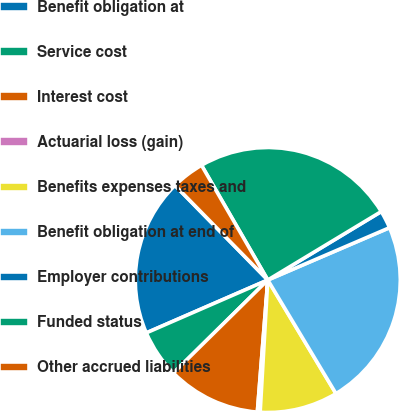Convert chart to OTSL. <chart><loc_0><loc_0><loc_500><loc_500><pie_chart><fcel>Benefit obligation at<fcel>Service cost<fcel>Interest cost<fcel>Actuarial loss (gain)<fcel>Benefits expenses taxes and<fcel>Benefit obligation at end of<fcel>Employer contributions<fcel>Funded status<fcel>Other accrued liabilities<nl><fcel>19.19%<fcel>5.85%<fcel>11.36%<fcel>0.34%<fcel>9.52%<fcel>22.86%<fcel>2.18%<fcel>24.7%<fcel>4.01%<nl></chart> 